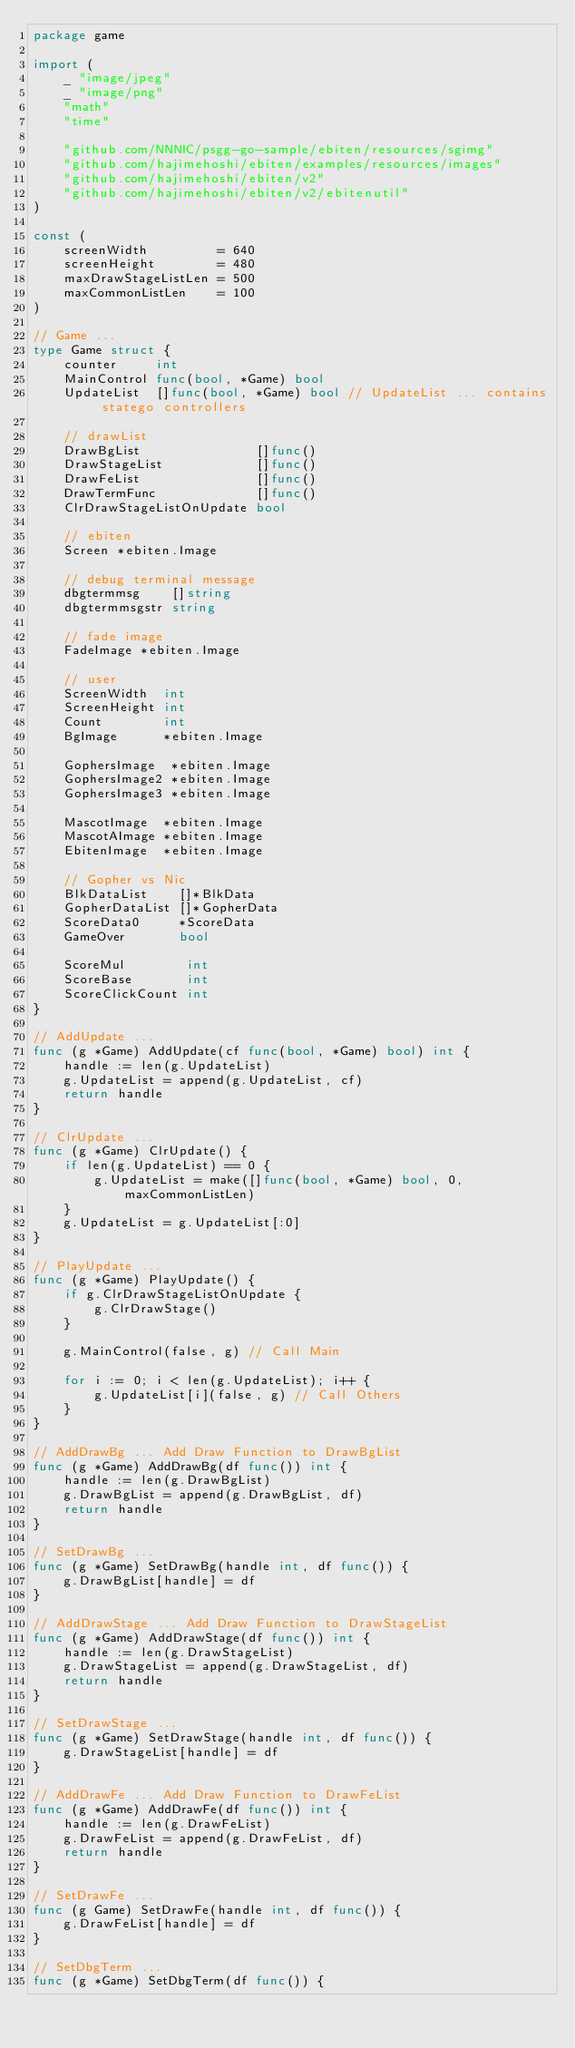Convert code to text. <code><loc_0><loc_0><loc_500><loc_500><_Go_>package game

import (
	_ "image/jpeg"
	_ "image/png"
	"math"
	"time"

	"github.com/NNNIC/psgg-go-sample/ebiten/resources/sgimg"
	"github.com/hajimehoshi/ebiten/examples/resources/images"
	"github.com/hajimehoshi/ebiten/v2"
	"github.com/hajimehoshi/ebiten/v2/ebitenutil"
)

const (
	screenWidth         = 640
	screenHeight        = 480
	maxDrawStageListLen = 500
	maxCommonListLen    = 100
)

// Game ...
type Game struct {
	counter     int
	MainControl func(bool, *Game) bool
	UpdateList  []func(bool, *Game) bool // UpdateList ... contains statego controllers

	// drawList
	DrawBgList               []func()
	DrawStageList            []func()
	DrawFeList               []func()
	DrawTermFunc             []func()
	ClrDrawStageListOnUpdate bool

	// ebiten
	Screen *ebiten.Image

	// debug terminal message
	dbgtermmsg    []string
	dbgtermmsgstr string

	// fade image
	FadeImage *ebiten.Image

	// user
	ScreenWidth  int
	ScreenHeight int
	Count        int
	BgImage      *ebiten.Image

	GophersImage  *ebiten.Image
	GophersImage2 *ebiten.Image
	GophersImage3 *ebiten.Image

	MascotImage  *ebiten.Image
	MascotAImage *ebiten.Image
	EbitenImage  *ebiten.Image

	// Gopher vs Nic
	BlkDataList    []*BlkData
	GopherDataList []*GopherData
	ScoreData0     *ScoreData
	GameOver       bool

	ScoreMul        int
	ScoreBase       int
	ScoreClickCount int
}

// AddUpdate ...
func (g *Game) AddUpdate(cf func(bool, *Game) bool) int {
	handle := len(g.UpdateList)
	g.UpdateList = append(g.UpdateList, cf)
	return handle
}

// ClrUpdate ...
func (g *Game) ClrUpdate() {
	if len(g.UpdateList) == 0 {
		g.UpdateList = make([]func(bool, *Game) bool, 0, maxCommonListLen)
	}
	g.UpdateList = g.UpdateList[:0]
}

// PlayUpdate ...
func (g *Game) PlayUpdate() {
	if g.ClrDrawStageListOnUpdate {
		g.ClrDrawStage()
	}

	g.MainControl(false, g) // Call Main

	for i := 0; i < len(g.UpdateList); i++ {
		g.UpdateList[i](false, g) // Call Others
	}
}

// AddDrawBg ... Add Draw Function to DrawBgList
func (g *Game) AddDrawBg(df func()) int {
	handle := len(g.DrawBgList)
	g.DrawBgList = append(g.DrawBgList, df)
	return handle
}

// SetDrawBg ...
func (g *Game) SetDrawBg(handle int, df func()) {
	g.DrawBgList[handle] = df
}

// AddDrawStage ... Add Draw Function to DrawStageList
func (g *Game) AddDrawStage(df func()) int {
	handle := len(g.DrawStageList)
	g.DrawStageList = append(g.DrawStageList, df)
	return handle
}

// SetDrawStage ...
func (g *Game) SetDrawStage(handle int, df func()) {
	g.DrawStageList[handle] = df
}

// AddDrawFe ... Add Draw Function to DrawFeList
func (g *Game) AddDrawFe(df func()) int {
	handle := len(g.DrawFeList)
	g.DrawFeList = append(g.DrawFeList, df)
	return handle
}

// SetDrawFe ...
func (g Game) SetDrawFe(handle int, df func()) {
	g.DrawFeList[handle] = df
}

// SetDbgTerm ...
func (g *Game) SetDbgTerm(df func()) {</code> 